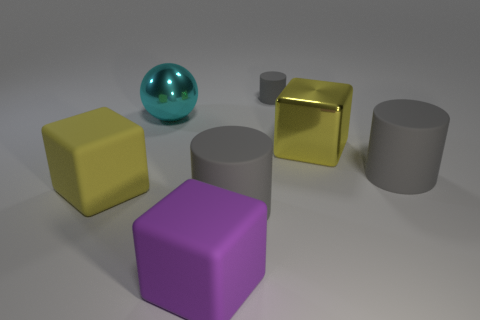What shape is the thing that is on the left side of the purple object and behind the large yellow metal object?
Your answer should be very brief. Sphere. What color is the tiny cylinder that is the same material as the big purple thing?
Make the answer very short. Gray. Is the number of yellow metal things on the left side of the tiny cylinder the same as the number of small yellow matte things?
Ensure brevity in your answer.  Yes. What shape is the yellow metallic thing that is the same size as the yellow matte thing?
Provide a short and direct response. Cube. How many other objects are there of the same shape as the purple thing?
Your answer should be compact. 2. There is a cyan ball; does it have the same size as the yellow metallic block that is on the right side of the large yellow matte object?
Provide a succinct answer. Yes. What number of objects are cyan metal objects in front of the small rubber cylinder or big matte things?
Your response must be concise. 5. The big rubber object behind the yellow matte cube has what shape?
Your response must be concise. Cylinder. Is the number of gray cylinders in front of the big yellow metal block the same as the number of large rubber things that are behind the purple cube?
Provide a succinct answer. No. What color is the block that is behind the big purple object and to the right of the large yellow matte cube?
Your answer should be very brief. Yellow. 